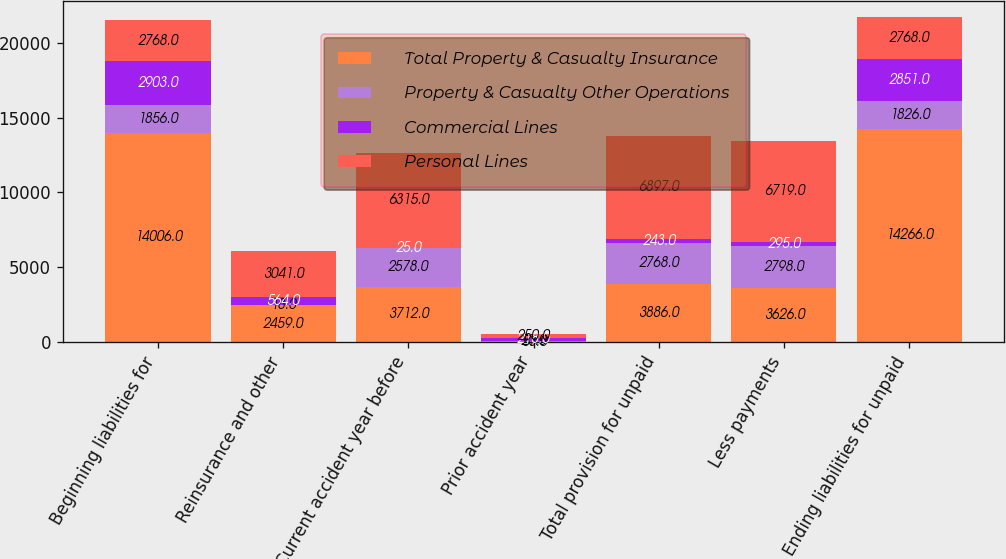<chart> <loc_0><loc_0><loc_500><loc_500><stacked_bar_chart><ecel><fcel>Beginning liabilities for<fcel>Reinsurance and other<fcel>Current accident year before<fcel>Prior accident year<fcel>Total provision for unpaid<fcel>Less payments<fcel>Ending liabilities for unpaid<nl><fcel>Total Property & Casualty Insurance<fcel>14006<fcel>2459<fcel>3712<fcel>53<fcel>3886<fcel>3626<fcel>14266<nl><fcel>Property & Casualty Other Operations<fcel>1856<fcel>18<fcel>2578<fcel>21<fcel>2768<fcel>2798<fcel>1826<nl><fcel>Commercial Lines<fcel>2903<fcel>564<fcel>25<fcel>218<fcel>243<fcel>295<fcel>2851<nl><fcel>Personal Lines<fcel>2768<fcel>3041<fcel>6315<fcel>250<fcel>6897<fcel>6719<fcel>2768<nl></chart> 